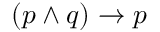Convert formula to latex. <formula><loc_0><loc_0><loc_500><loc_500>( p \land q ) \to p</formula> 